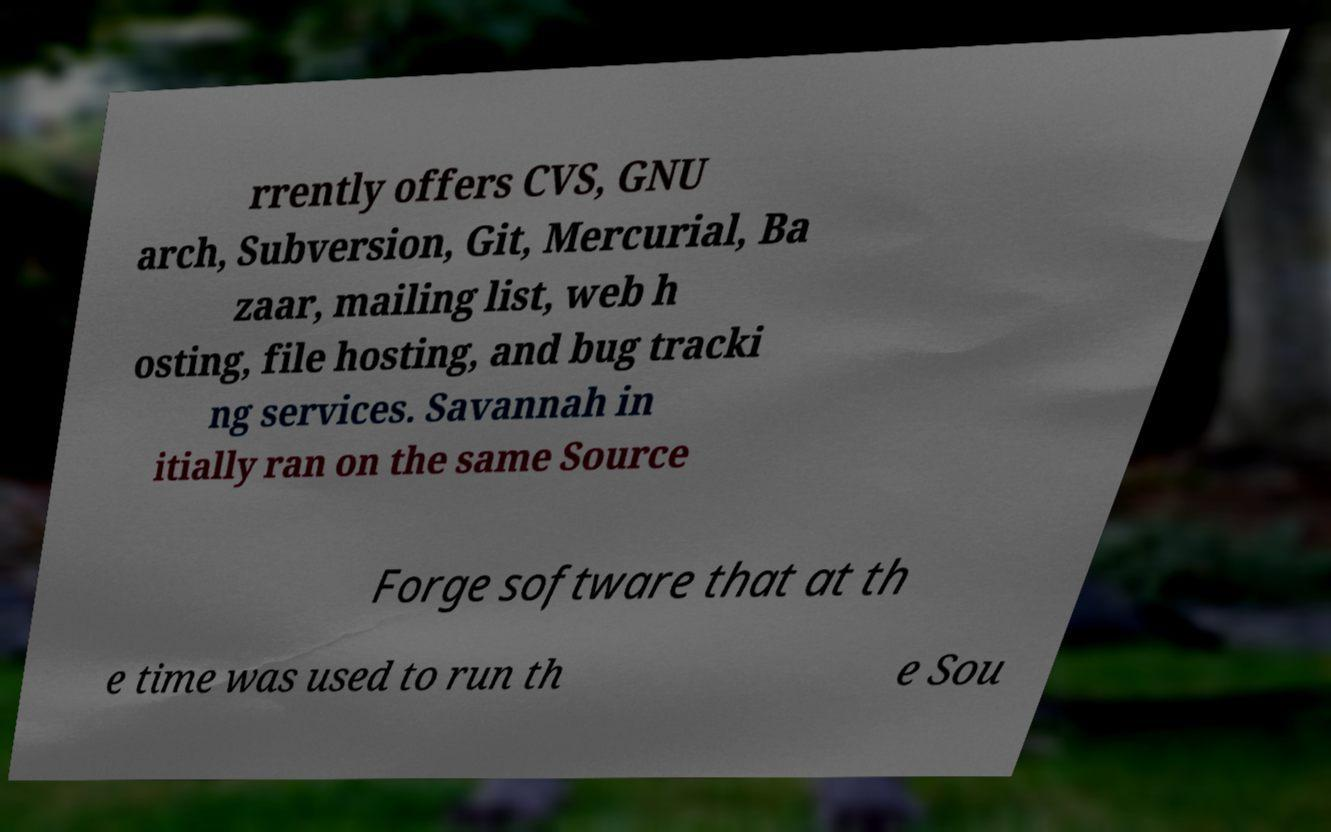I need the written content from this picture converted into text. Can you do that? rrently offers CVS, GNU arch, Subversion, Git, Mercurial, Ba zaar, mailing list, web h osting, file hosting, and bug tracki ng services. Savannah in itially ran on the same Source Forge software that at th e time was used to run th e Sou 